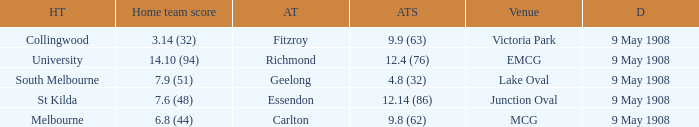Name the home team for carlton away team Melbourne. 